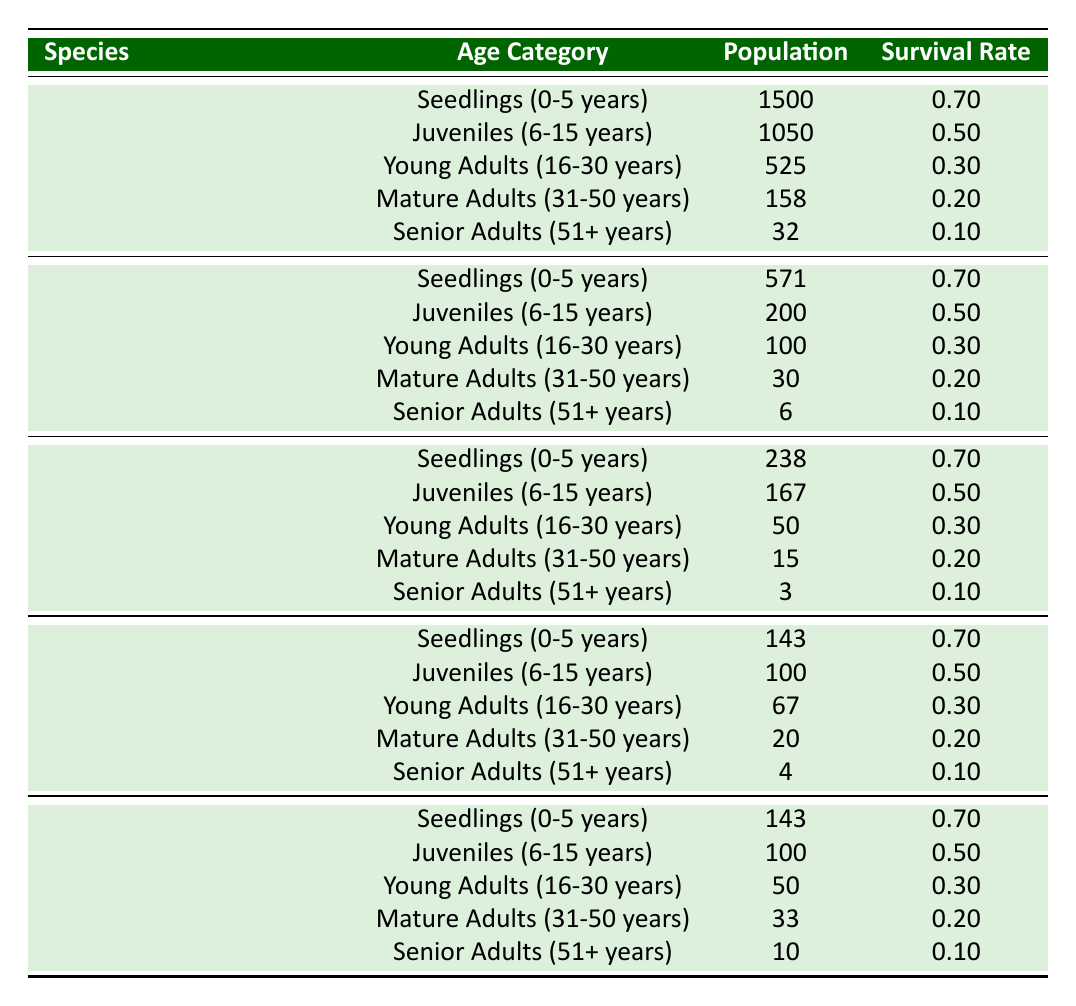What is the population of Seedlings for the Wollemi Pine? According to the table, the population listed under the age category "Seedlings (0-5 years)" for the Wollemi Pine is 1500.
Answer: 1500 What is the survival rate of Senior Adults for the Rafflesia arnoldii? The survival rate for Senior Adults (51+ years) for the Rafflesia arnoldii is shown in the table as 0.10.
Answer: 0.10 Which species has the highest population in the Juveniles age category? From the table, the Wollemi Pine has a population of 1050 in the Juveniles age category, which is higher than the 200 for the Himalayan Blue Poppy and lower populations for other species.
Answer: Wollemi Pine What percentage of the population survives from Young Adults to Senior Adults for the Corpse Flower? Starting with 67 young adults with a survival rate of 0.30 down to 4 senior adults with a survival rate of 0.10, we calculate the survival as follows: (67 * 0.30) = 20.1 (approx 20 mature adults). Of those, (20 * 0.20) = 4 survives into senior adults. Therefore, the percentage of young adults that survive to senior adults is (4/67)*100 ≈ 5.97%.
Answer: 5.97% Is the survival rate for Mature Adults and Senior Adults the same across all species? The survival rates for Mature Adults (31-50 years) and Senior Adults (51+ years) are not the same for each species. Looking at the table: Wollemi Pine has 0.20 and 0.10, Himalayan Blue Poppy has 0.20 and 0.10, Rafflesia arnoldii has 0.20 and 0.10, Corpse Flower has 0.20 and 0.10, and Adenium obesum has 0.20 and 0.10. So, this is consistent across all species.
Answer: No 